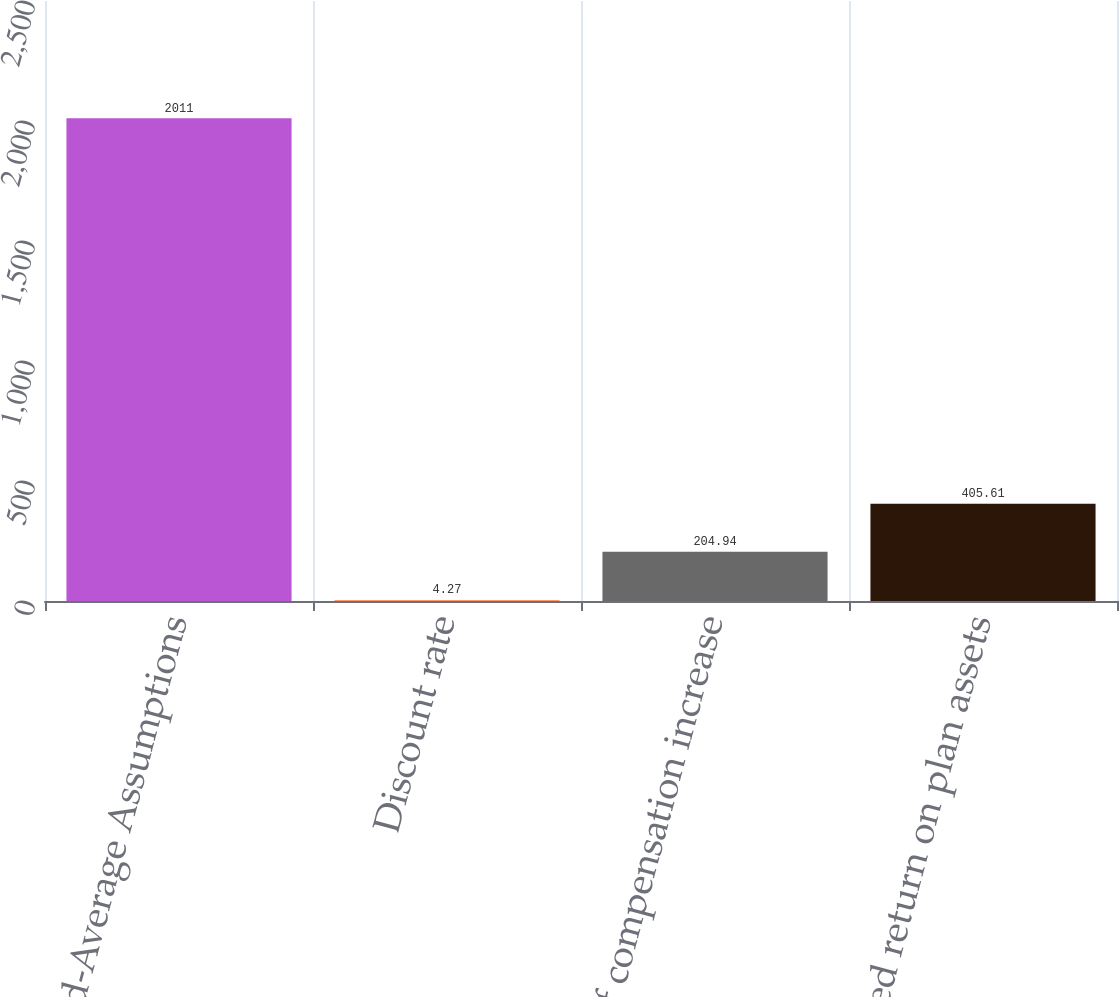<chart> <loc_0><loc_0><loc_500><loc_500><bar_chart><fcel>Weighted-Average Assumptions<fcel>Discount rate<fcel>Rate of compensation increase<fcel>Expected return on plan assets<nl><fcel>2011<fcel>4.27<fcel>204.94<fcel>405.61<nl></chart> 